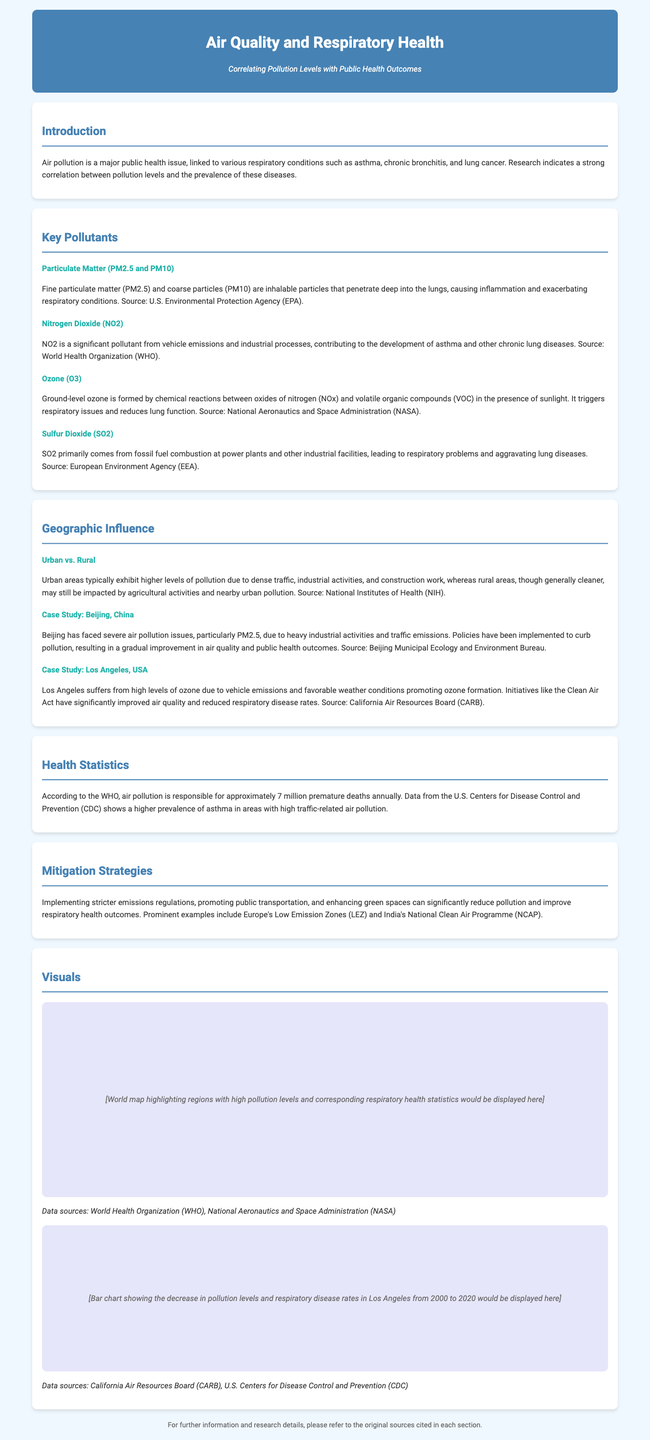What is the title of the infographic? The title of the infographic is presented in the header section indicating the main topic being discussed.
Answer: Air Quality and Respiratory Health What pollutant is indicated as a significant contributor from vehicle emissions? The document specifies nitrogen dioxide as a significant pollutant from vehicle emissions.
Answer: Nitrogen Dioxide (NO2) How many premature deaths are attributed to air pollution annually according to WHO? The document cites that air pollution is responsible for approximately a specific number of deaths as stated in the health statistics section.
Answer: 7 million Which city is used as a case study for severe air pollution issues? The document references Beijing as a city that has faced severe air pollution challenges.
Answer: Beijing, China What strategies are suggested to mitigate air pollution? The document lists several strategies for reducing pollution, emphasizing specific approaches to improve public health outcomes.
Answer: Stricter emissions regulations Which organization sources indicate a higher prevalence of asthma in polluted areas? The document references specific organizations that provide statistics concerning asthma prevalence related to air pollution.
Answer: U.S. Centers for Disease Control and Prevention (CDC) What pollutant is primarily associated with ground-level ozone? The document explains the formation of ground-level ozone is related to specific chemical reactions involving pollutants.
Answer: Oxides of nitrogen (NOx) What significant air quality improvement initiative is mentioned for Los Angeles? The document discusses a specific legislation that has contributed to air quality improvements in Los Angeles.
Answer: Clean Air Act 